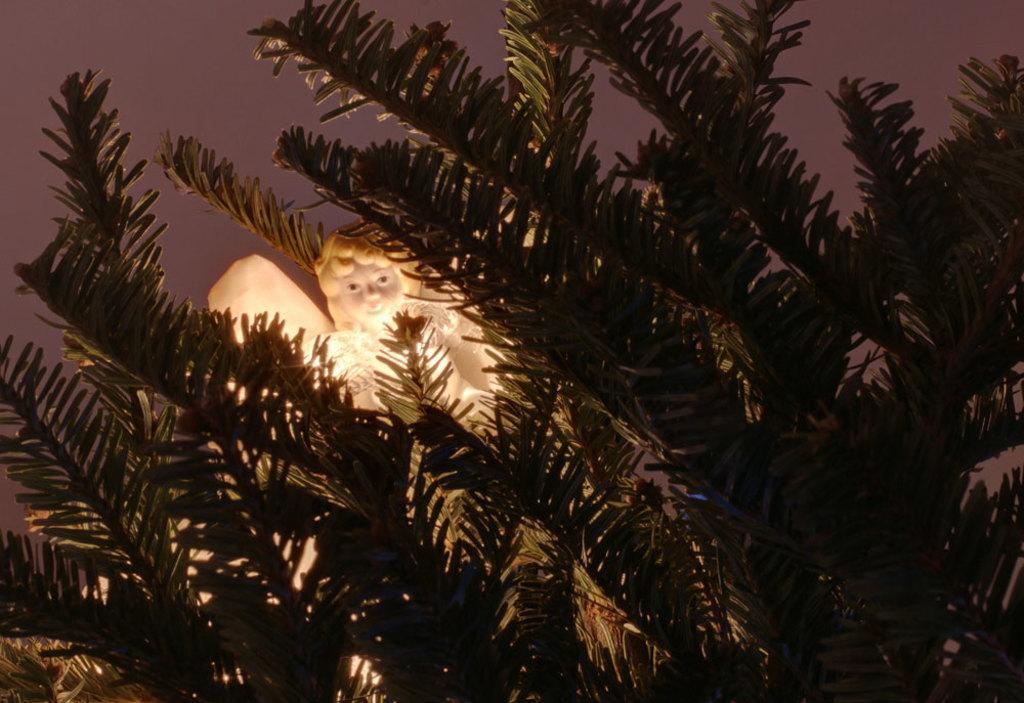How would you summarize this image in a sentence or two? In this image I can see a doll and a plant. 